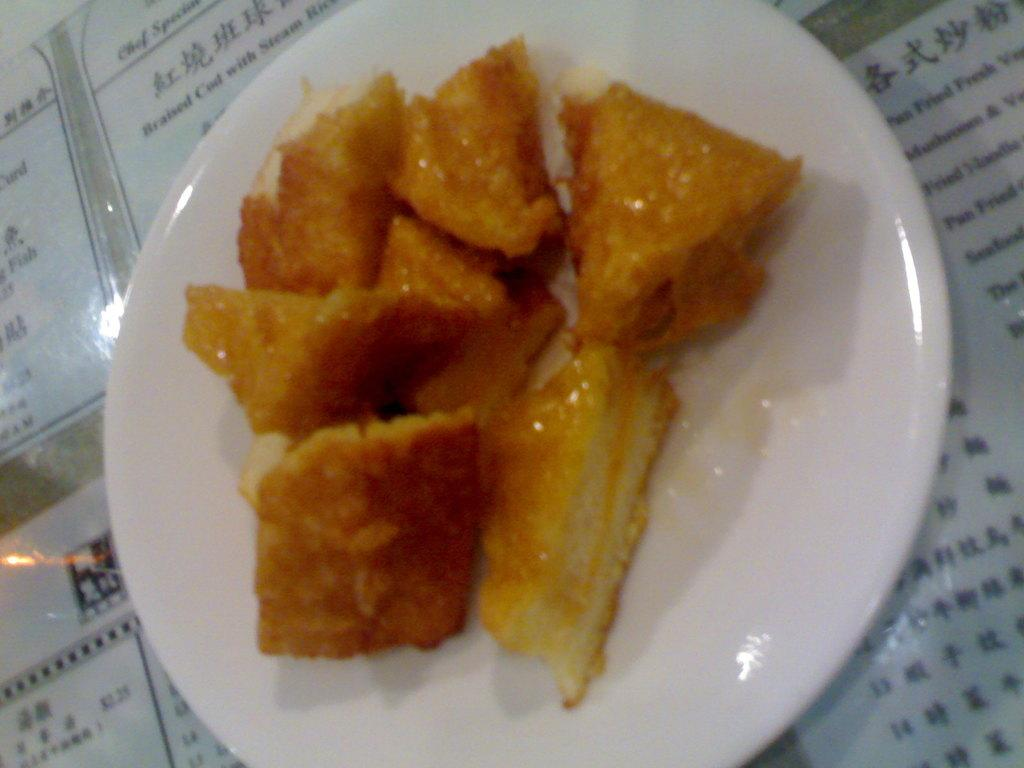What is on the plate in the image? There are food items on a plate in the image. What else can be seen under the plate in the image? There are objects that resemble menu cards under the plate in the image. What type of fear can be seen on the elbow of the person in the image? There is no person or elbow present in the image; it only features a plate with food items and objects resembling menu cards. 